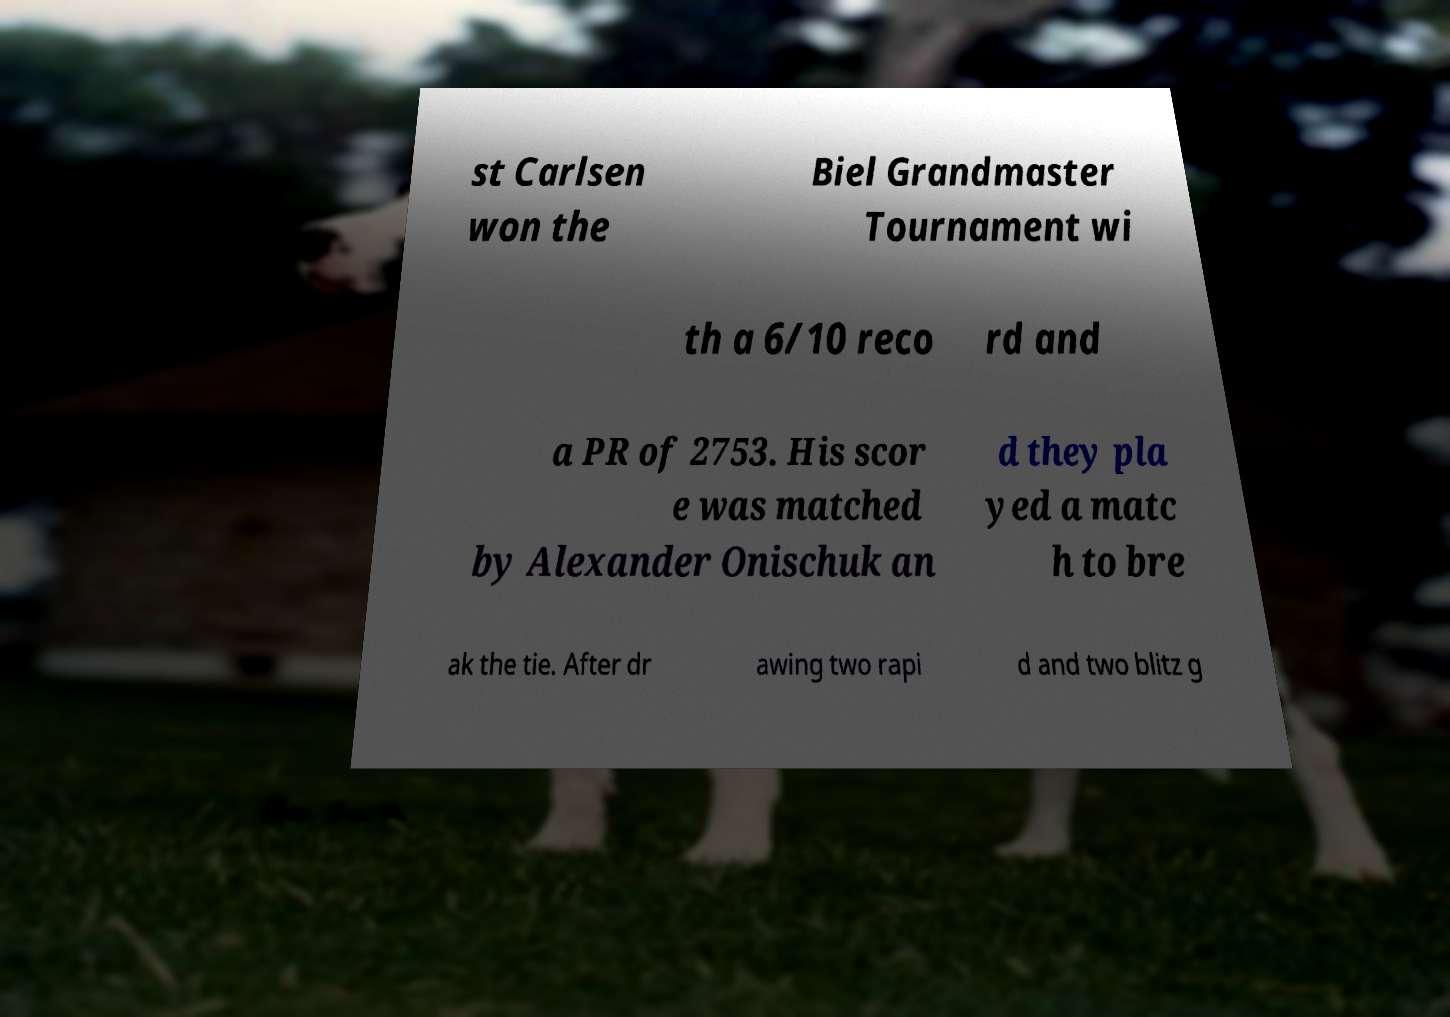What messages or text are displayed in this image? I need them in a readable, typed format. st Carlsen won the Biel Grandmaster Tournament wi th a 6/10 reco rd and a PR of 2753. His scor e was matched by Alexander Onischuk an d they pla yed a matc h to bre ak the tie. After dr awing two rapi d and two blitz g 